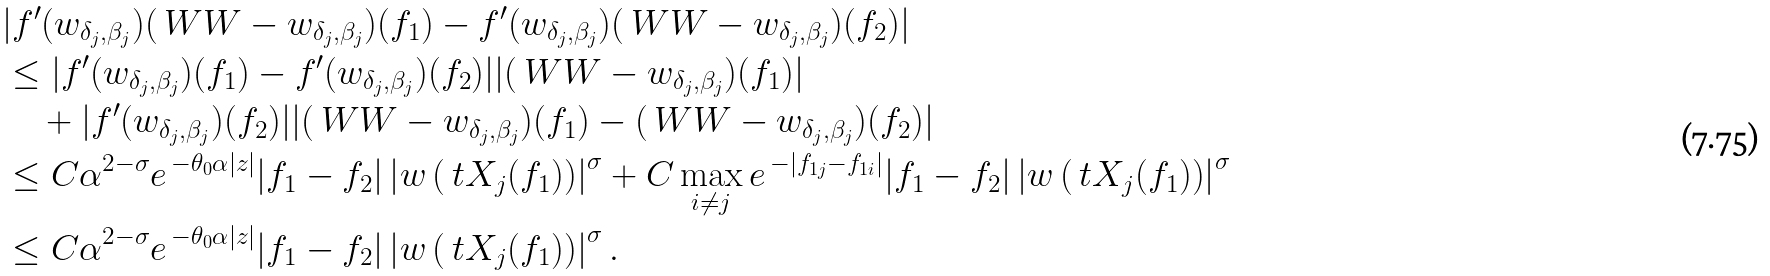<formula> <loc_0><loc_0><loc_500><loc_500>& | f ^ { \prime } ( w _ { \delta _ { j } , \beta _ { j } } ) ( \ W W - w _ { \delta _ { j } , \beta _ { j } } ) ( { f } _ { 1 } ) - f ^ { \prime } ( w _ { \delta _ { j } , \beta _ { j } } ) ( \ W W - w _ { \delta _ { j } , \beta _ { j } } ) ( { f } _ { 2 } ) | \\ & \leq | f ^ { \prime } ( w _ { \delta _ { j } , \beta _ { j } } ) ( { f } _ { 1 } ) - f ^ { \prime } ( w _ { \delta _ { j } , \beta _ { j } } ) ( { f } _ { 2 } ) | | ( \ W W - w _ { \delta _ { j } , \beta _ { j } } ) ( { f } _ { 1 } ) | \\ & \quad + | f ^ { \prime } ( w _ { \delta _ { j } , \beta _ { j } } ) ( { f } _ { 2 } ) | | ( \ W W - w _ { \delta _ { j } , \beta _ { j } } ) ( { f } _ { 1 } ) - ( \ W W - w _ { \delta _ { j } , \beta _ { j } } ) ( { f } _ { 2 } ) | \\ & \leq C \alpha ^ { 2 - \sigma } e ^ { \, - \theta _ { 0 } \alpha | z | } | { f } _ { 1 } - { f } _ { 2 } | \left | w \left ( \ t X _ { j } ( { f } _ { 1 } ) \right ) \right | ^ { \sigma } + C \max _ { i \neq j } e ^ { \, - | f _ { 1 j } - f _ { 1 i } | } | { f } _ { 1 } - { f } _ { 2 } | \left | w \left ( \ t X _ { j } ( { f } _ { 1 } ) \right ) \right | ^ { \sigma } \\ & \leq C \alpha ^ { 2 - \sigma } e ^ { \, - \theta _ { 0 } \alpha | z | } | { f } _ { 1 } - { f } _ { 2 } | \left | w \left ( \ t X _ { j } ( { f } _ { 1 } ) \right ) \right | ^ { \sigma } .</formula> 